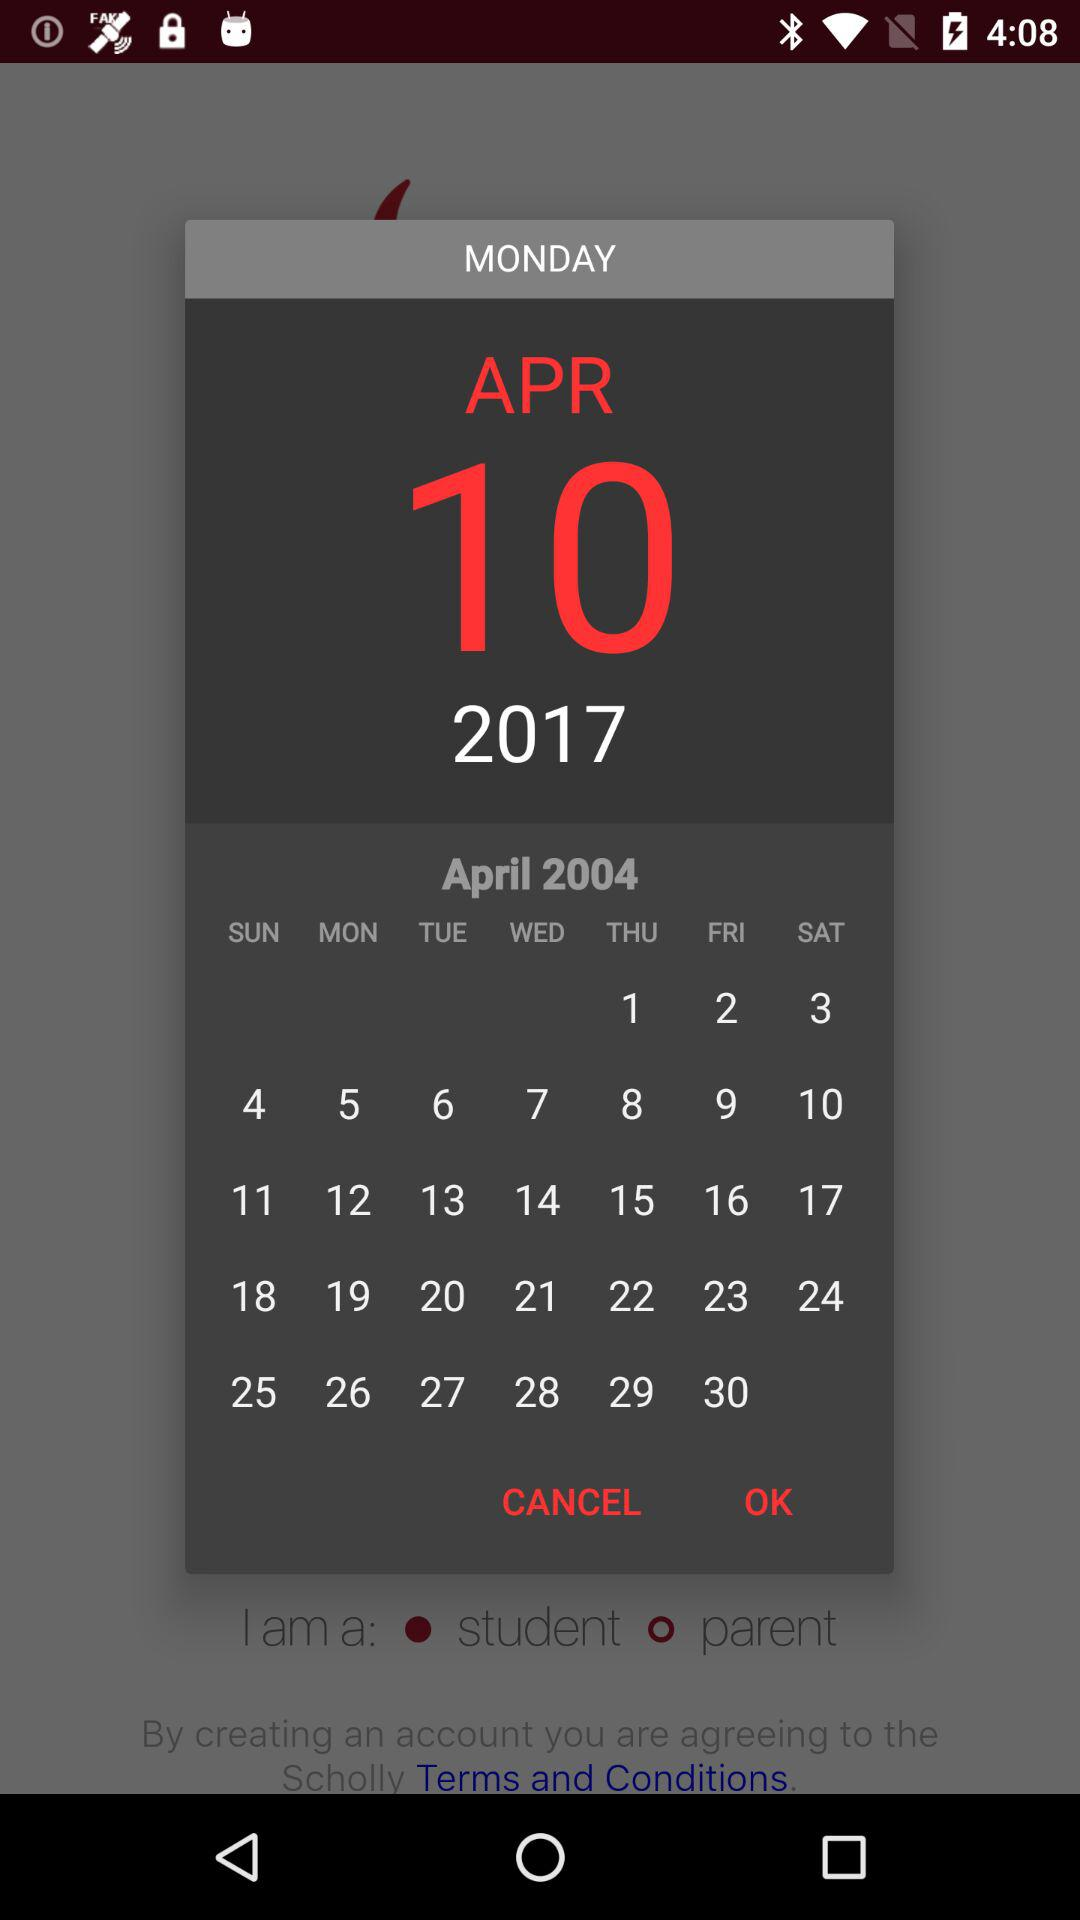What is the selected date? The selected date is Monday, April 10, 2017. 